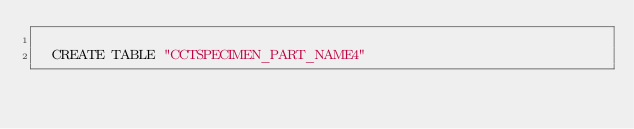<code> <loc_0><loc_0><loc_500><loc_500><_SQL_>
  CREATE TABLE "CCTSPECIMEN_PART_NAME4" </code> 